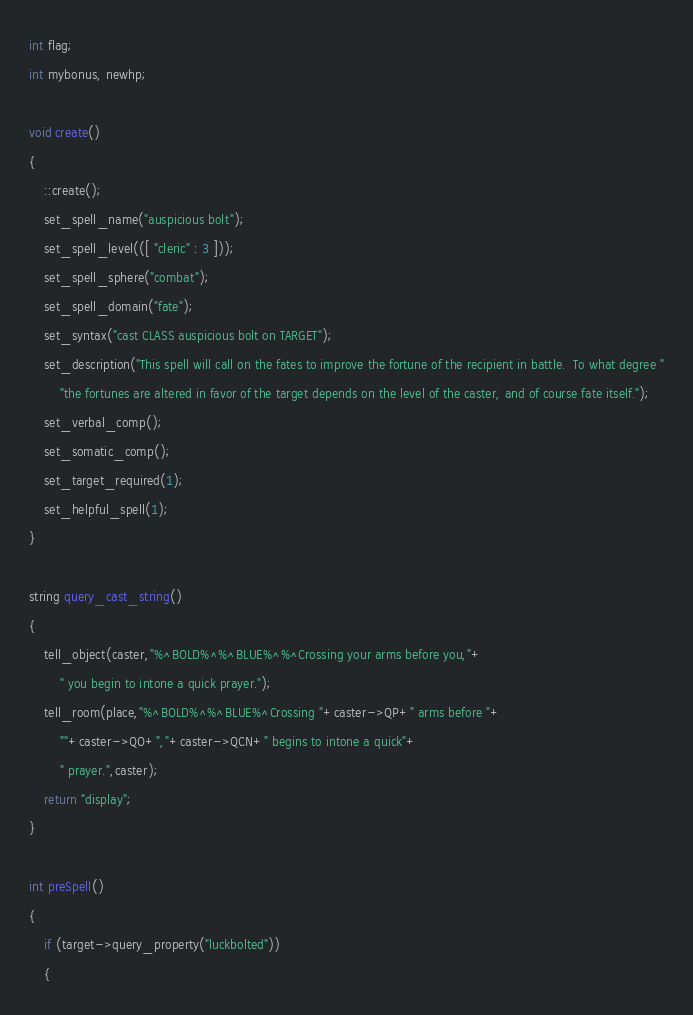<code> <loc_0><loc_0><loc_500><loc_500><_C_>int flag;
int mybonus, newhp;

void create()
{
    ::create();
    set_spell_name("auspicious bolt");
    set_spell_level(([ "cleric" : 3 ]));
    set_spell_sphere("combat");
    set_spell_domain("fate");
    set_syntax("cast CLASS auspicious bolt on TARGET");
    set_description("This spell will call on the fates to improve the fortune of the recipient in battle.  To what degree "
        "the fortunes are altered in favor of the target depends on the level of the caster, and of course fate itself.");
    set_verbal_comp();
    set_somatic_comp();
    set_target_required(1);
    set_helpful_spell(1);
}

string query_cast_string()
{
    tell_object(caster,"%^BOLD%^%^BLUE%^%^Crossing your arms before you,"+
        " you begin to intone a quick prayer.");
    tell_room(place,"%^BOLD%^%^BLUE%^Crossing "+caster->QP+" arms before "+
        ""+caster->QO+","+caster->QCN+" begins to intone a quick"+
        " prayer.",caster);
    return "display";
}

int preSpell()
{
    if (target->query_property("luckbolted"))
    {</code> 